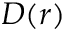<formula> <loc_0><loc_0><loc_500><loc_500>D ( r )</formula> 